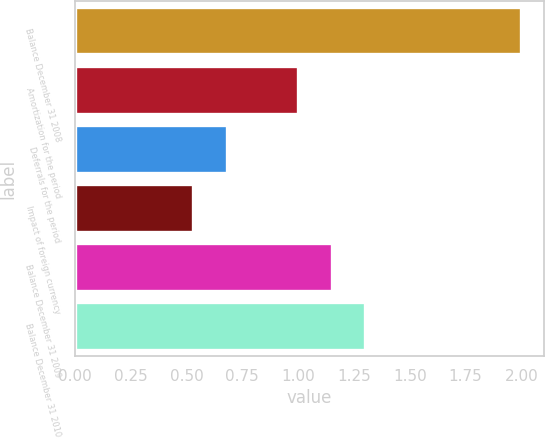Convert chart to OTSL. <chart><loc_0><loc_0><loc_500><loc_500><bar_chart><fcel>Balance December 31 2008<fcel>Amortization for the period<fcel>Deferrals for the period<fcel>Impact of foreign currency<fcel>Balance December 31 2009<fcel>Balance December 31 2010<nl><fcel>2<fcel>1<fcel>0.68<fcel>0.53<fcel>1.15<fcel>1.3<nl></chart> 